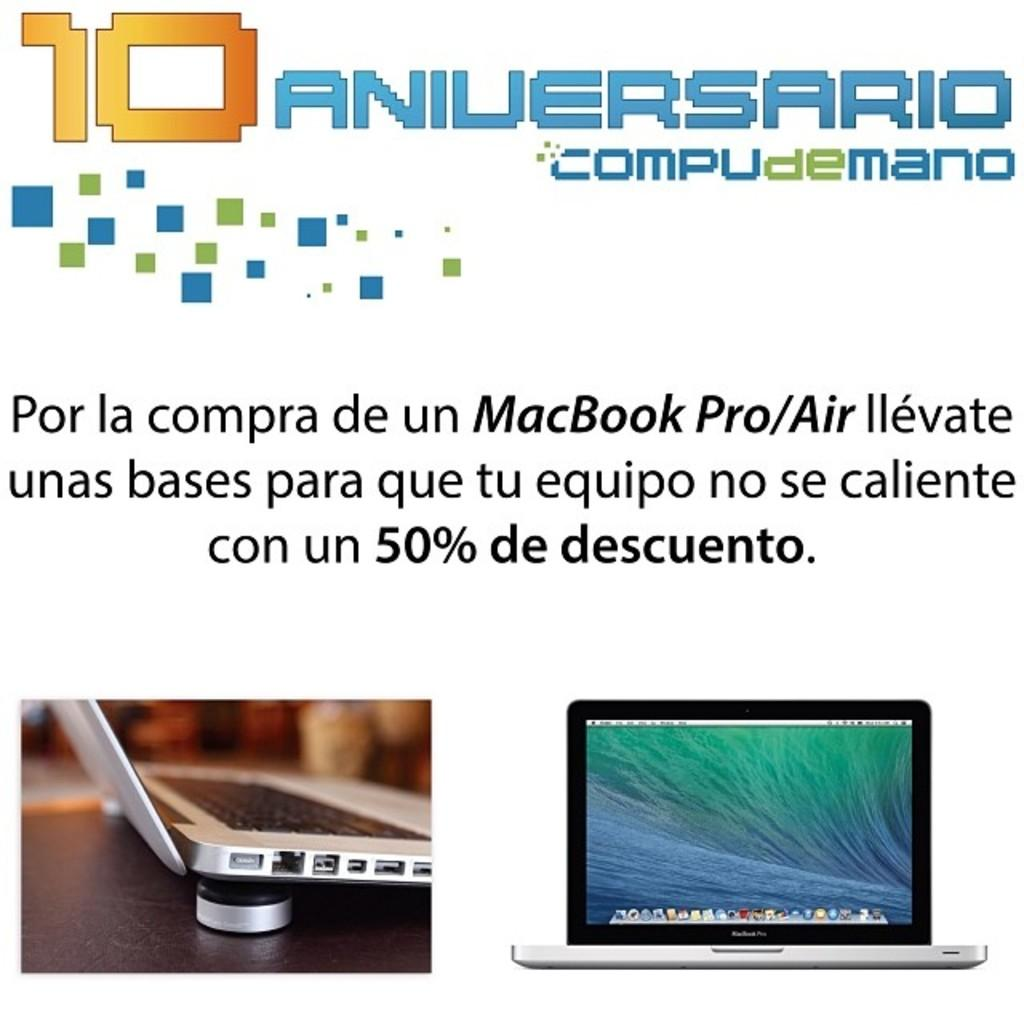<image>
Relay a brief, clear account of the picture shown. COMPUdeMANO is celebrating their 10 Year anniversary by offering a 50% discount on the MacBook Pro/Air. 